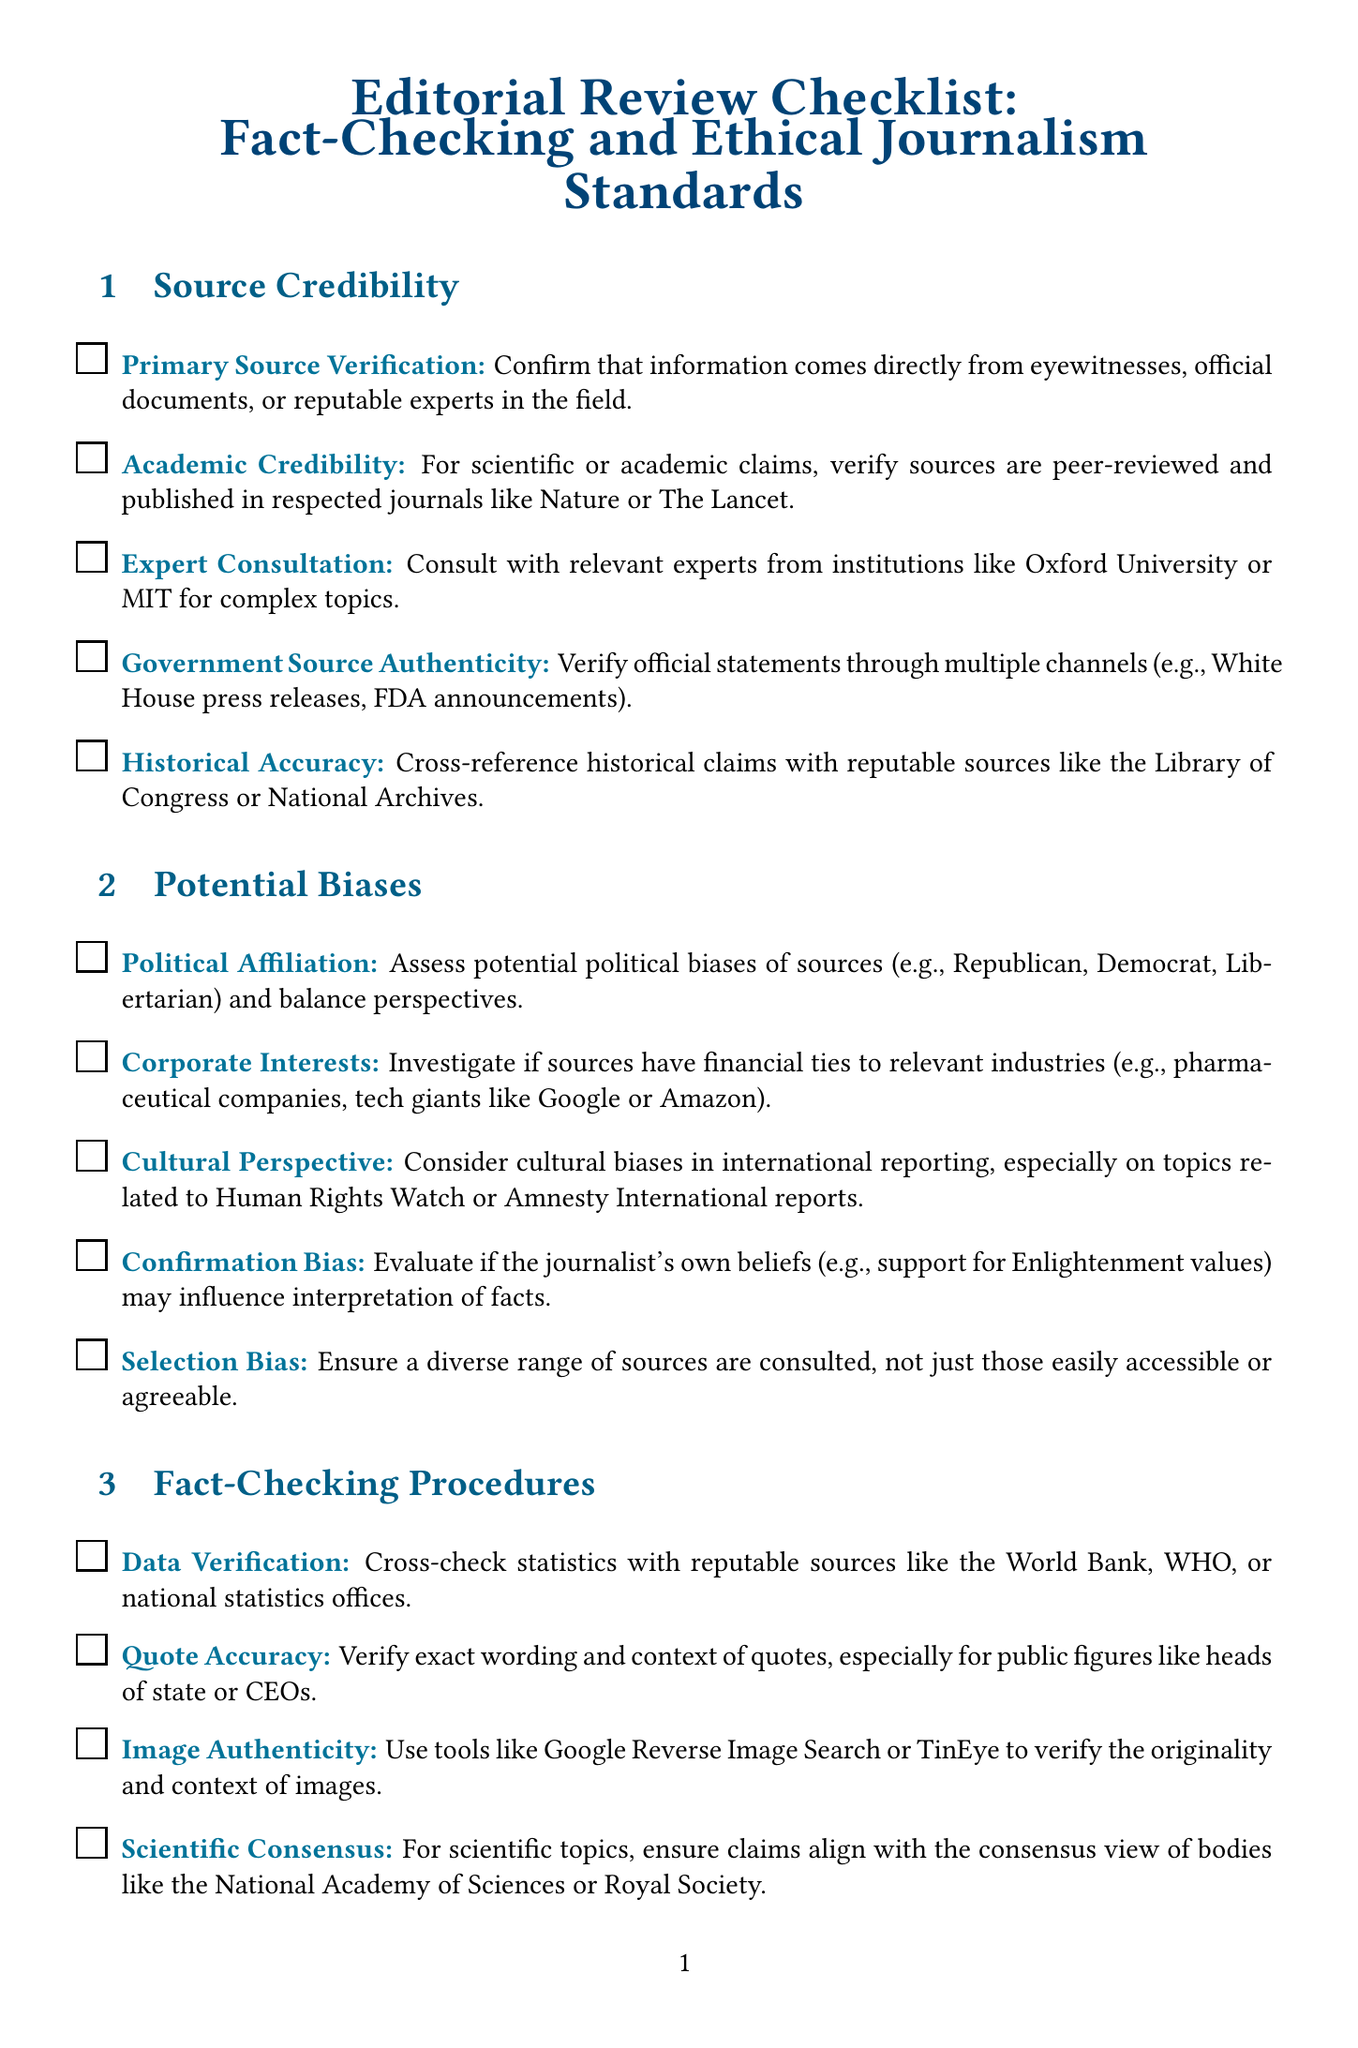What is the title of the document? The title of the document is stated at the top and provides the main focus of the form.
Answer: Editorial Review Checklist: Fact-Checking and Ethical Journalism Standards How many sections are in the document? The document lists several sections; counting them reveals the total number of sections included.
Answer: 4 What is the first item under Source Credibility? The document lists items within each section, and the first item in the Source Credibility section can be directly identified from the content.
Answer: Primary Source Verification Name one organization mentioned for fact-checking procedures. The document cites specific organizations to check facts, and one can be found in the Fact-Checking Procedures section.
Answer: Snopes What concept is evaluated under Potential Biases regarding personal beliefs? The document discusses potential influences on interpretation of facts, particularly regarding the journalist’s beliefs in the section on biases.
Answer: Confirmation Bias Which ethical standard emphasizes fair response opportunities? The document outlines practices that uphold ethical journalism; identifying the item related to allowing responses reveals this standard.
Answer: Right to Reply List one type of source necessary for Academic Credibility. The document specifies that certain types of sources must be verified for credibility; identifying them points to what is needed for Academic Credibility.
Answer: Respected journals What does the Public Interest Test evaluate? The document specifies that this item assesses if a story serves a particular criterion related to journalism standards.
Answer: Public interest 